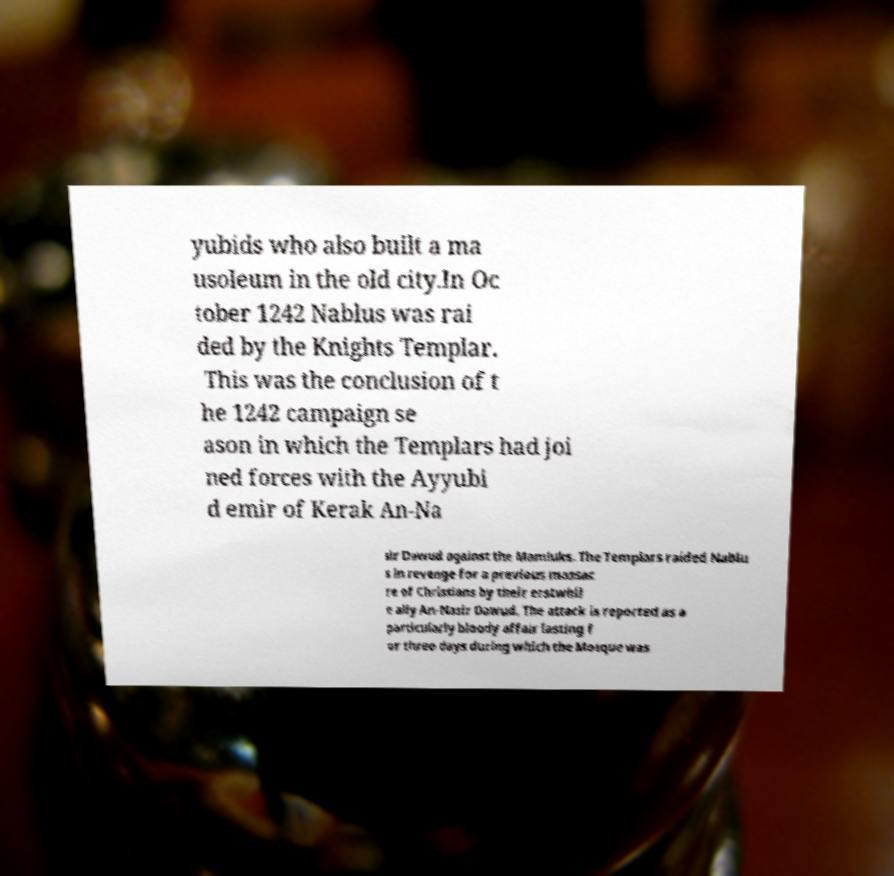Please identify and transcribe the text found in this image. yubids who also built a ma usoleum in the old city.In Oc tober 1242 Nablus was rai ded by the Knights Templar. This was the conclusion of t he 1242 campaign se ason in which the Templars had joi ned forces with the Ayyubi d emir of Kerak An-Na sir Dawud against the Mamluks. The Templars raided Nablu s in revenge for a previous massac re of Christians by their erstwhil e ally An-Nasir Dawud. The attack is reported as a particularly bloody affair lasting f or three days during which the Mosque was 